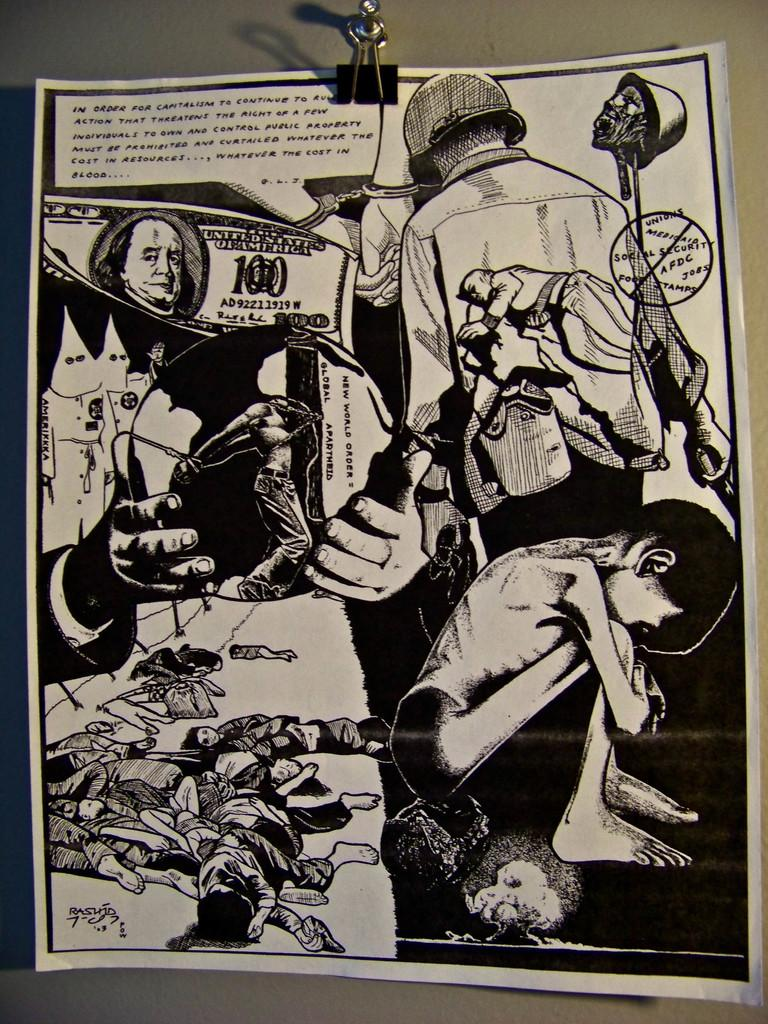<image>
Share a concise interpretation of the image provided. a 100 dollar bill is next to many depressing photos 